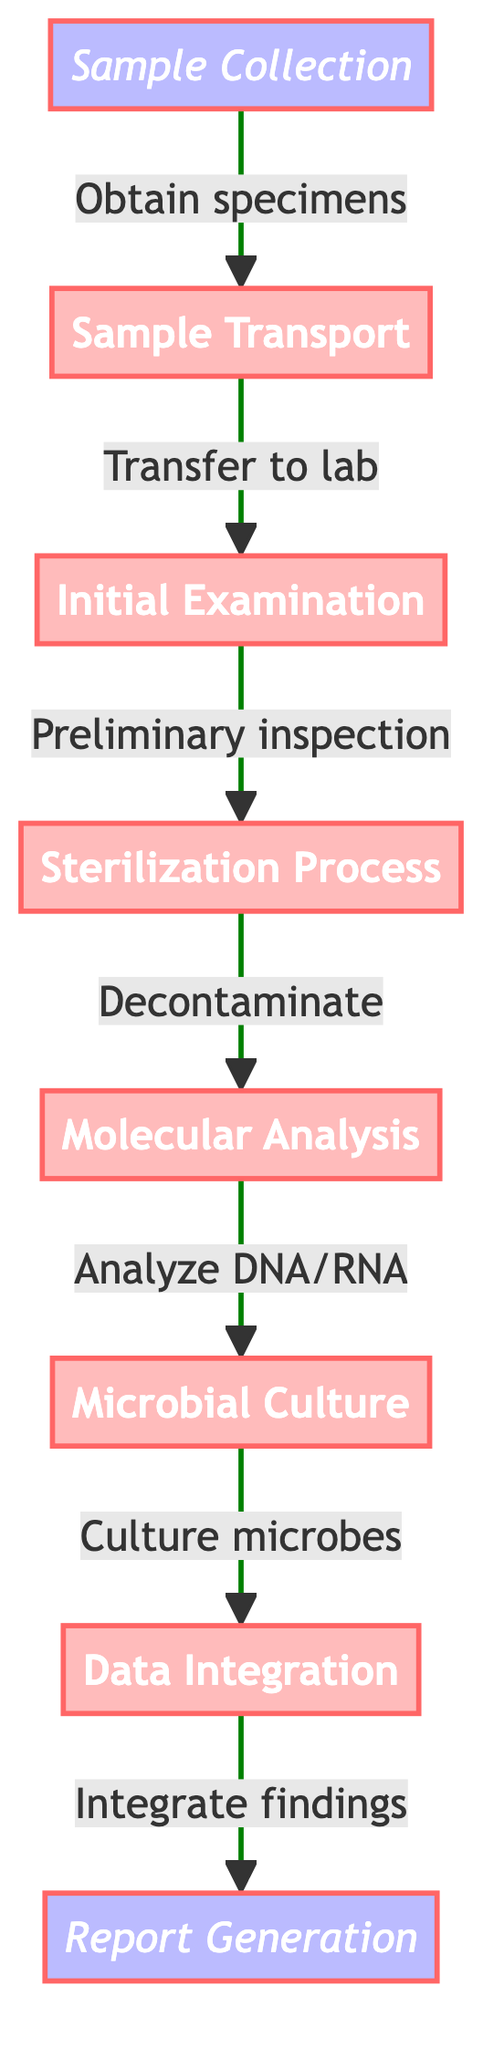What is the first step in the pathway? The diagram starts with "Sample Collection," which is the first node in the flow.
Answer: Sample Collection How many steps are in the pathway? The diagram lists a total of eight nodes, including both starting and ending points.
Answer: Eight What process comes after Molecular Analysis? Following "Molecular Analysis," the next step outlined in the pathway is "Microbial Culture."
Answer: Microbial Culture What is the purpose of the Sterilization Process? The description in the diagram specifies that this step aims to "Decontaminate samples to prevent Earth organism contamination."
Answer: Decontaminate samples Which step integrates findings with existing databases? The node titled "Data Integration" is specifically designated for integrating findings with existing astrobiological databases and missions.
Answer: Data Integration What is the final output of this clinical pathway? The last step in the flow is "Report Generation," which explains that results are compiled and sent to mission control.
Answer: Report Generation How many processes occur after Sample Transport? Following "Sample Transport," there are five processes until the last output, beginning with "Initial Examination" and ending with "Report Generation."
Answer: Five What is the main focus of the Microbial Culture step? The Microbial Culture step aims to "Attempt to culture potential extraterrestrial microbes in controlled environments."
Answer: Attempt to culture microbes Which two steps are connected by the transition phrase "Analyze DNA/RNA"? The phrase "Analyze DNA/RNA" connects the steps "Molecular Analysis" and "Microbial Culture" in the pathway.
Answer: Molecular Analysis and Microbial Culture 